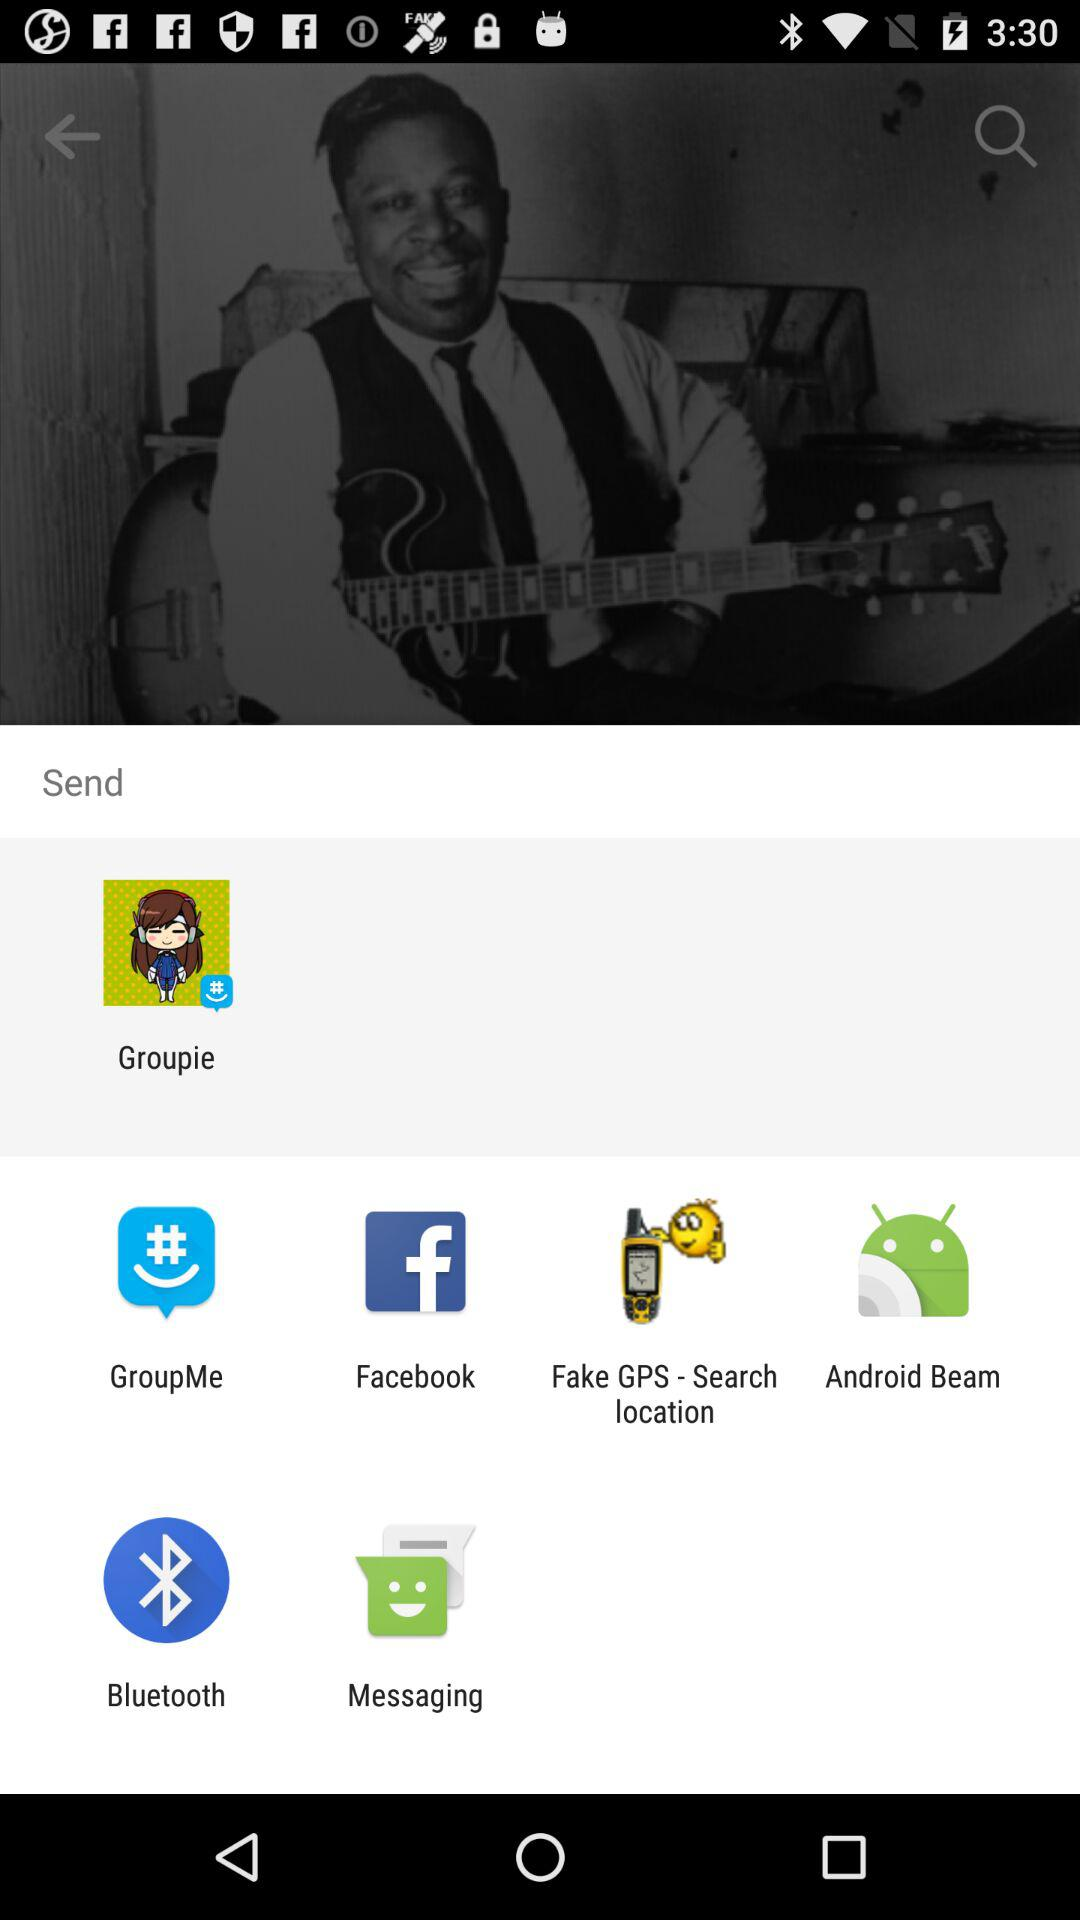Through what application can we send it? We can send it through "Groupie", "GroupMe", "Facebook", "Fake GPS-Search location", "Android Beam", "Bluetooth", and "Messaging". 